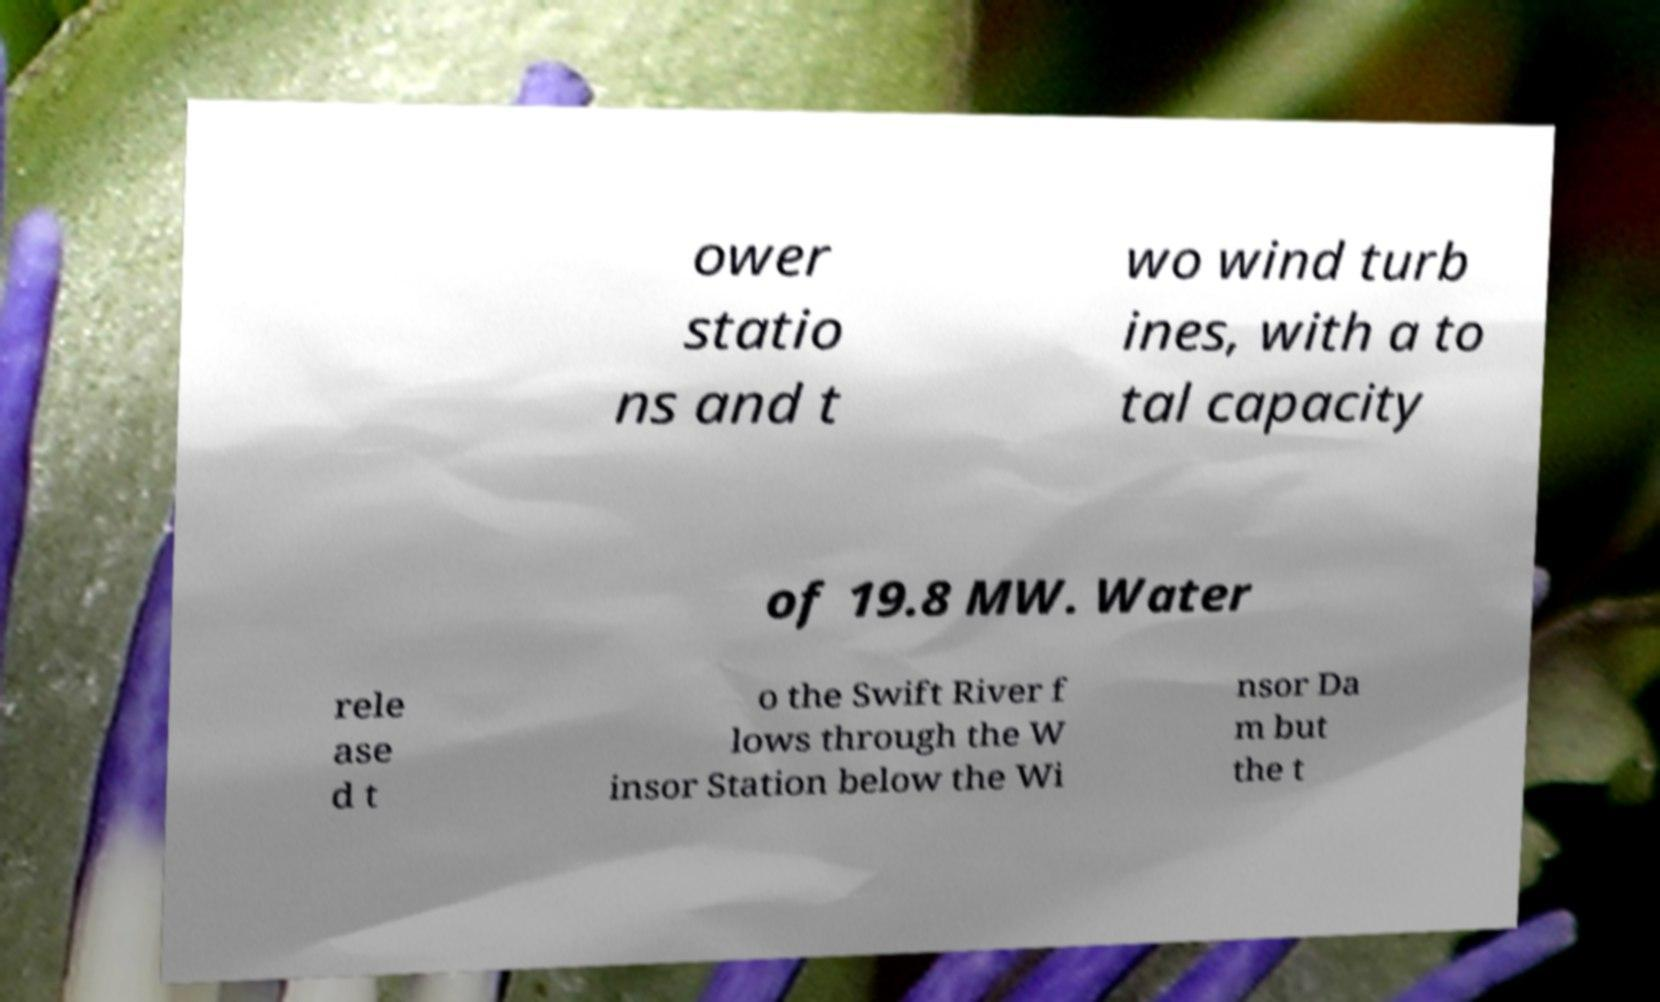Can you accurately transcribe the text from the provided image for me? ower statio ns and t wo wind turb ines, with a to tal capacity of 19.8 MW. Water rele ase d t o the Swift River f lows through the W insor Station below the Wi nsor Da m but the t 